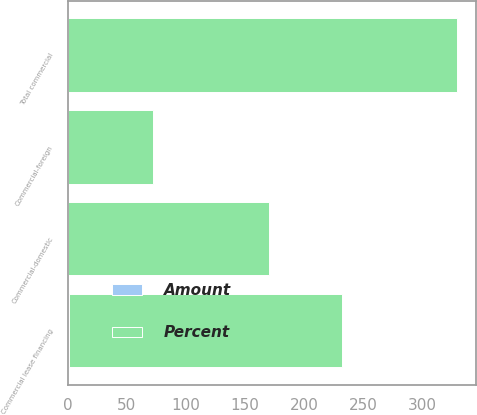<chart> <loc_0><loc_0><loc_500><loc_500><stacked_bar_chart><ecel><fcel>Commercial-domestic<fcel>Commercial lease financing<fcel>Commercial-foreign<fcel>Total commercial<nl><fcel>Percent<fcel>170<fcel>231<fcel>72<fcel>329<nl><fcel>Amount<fcel>0.13<fcel>1.13<fcel>0.39<fcel>0.16<nl></chart> 